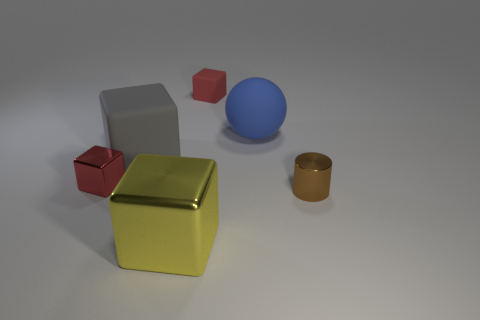Is the number of gray cubes greater than the number of green metallic things?
Provide a short and direct response. Yes. What is the big object that is behind the tiny shiny block and right of the large gray matte block made of?
Ensure brevity in your answer.  Rubber. What number of other objects are there of the same material as the big gray block?
Your response must be concise. 2. What number of large balls are the same color as the small metal cylinder?
Your response must be concise. 0. What is the size of the red object that is left of the big cube that is on the right side of the rubber cube in front of the small rubber block?
Ensure brevity in your answer.  Small. What number of metallic things are either large gray objects or tiny spheres?
Offer a very short reply. 0. There is a yellow metal object; is its shape the same as the small red object that is right of the big gray matte object?
Offer a terse response. Yes. Are there more objects that are to the right of the tiny red metallic thing than rubber blocks that are in front of the large blue ball?
Offer a terse response. Yes. Are there any other things that have the same color as the big matte block?
Your answer should be compact. No. Are there any tiny blocks that are on the right side of the small red thing to the left of the small thing that is behind the big blue object?
Your answer should be very brief. Yes. 